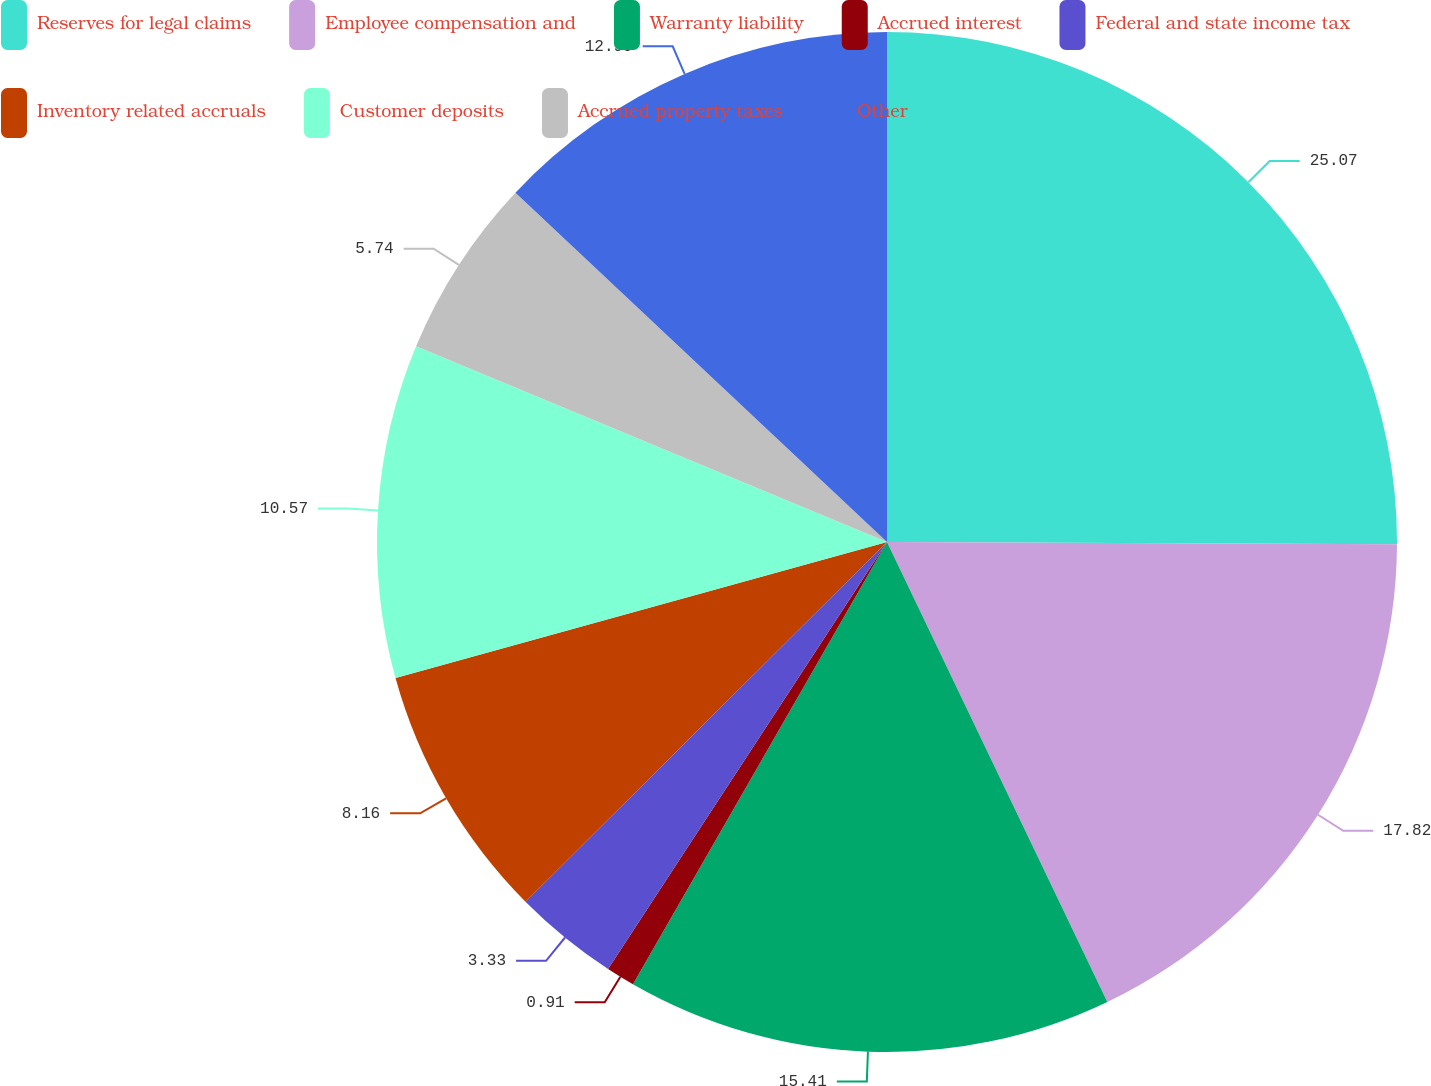Convert chart. <chart><loc_0><loc_0><loc_500><loc_500><pie_chart><fcel>Reserves for legal claims<fcel>Employee compensation and<fcel>Warranty liability<fcel>Accrued interest<fcel>Federal and state income tax<fcel>Inventory related accruals<fcel>Customer deposits<fcel>Accrued property taxes<fcel>Other<nl><fcel>25.07%<fcel>17.82%<fcel>15.41%<fcel>0.91%<fcel>3.33%<fcel>8.16%<fcel>10.57%<fcel>5.74%<fcel>12.99%<nl></chart> 